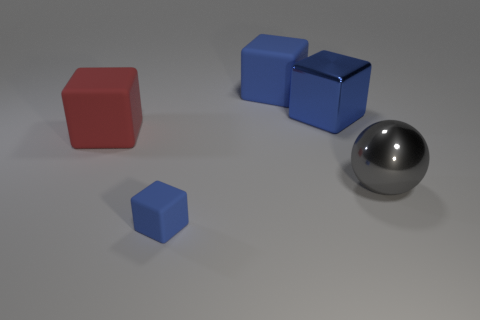Subtract all blue blocks. How many were subtracted if there are1blue blocks left? 2 Add 1 large blocks. How many objects exist? 6 Subtract all red blocks. How many blocks are left? 3 Subtract 3 cubes. How many cubes are left? 1 Subtract all large cubes. How many cubes are left? 1 Subtract all small cylinders. Subtract all shiny blocks. How many objects are left? 4 Add 3 large blue metal things. How many large blue metal things are left? 4 Add 5 brown cylinders. How many brown cylinders exist? 5 Subtract 0 blue cylinders. How many objects are left? 5 Subtract all spheres. How many objects are left? 4 